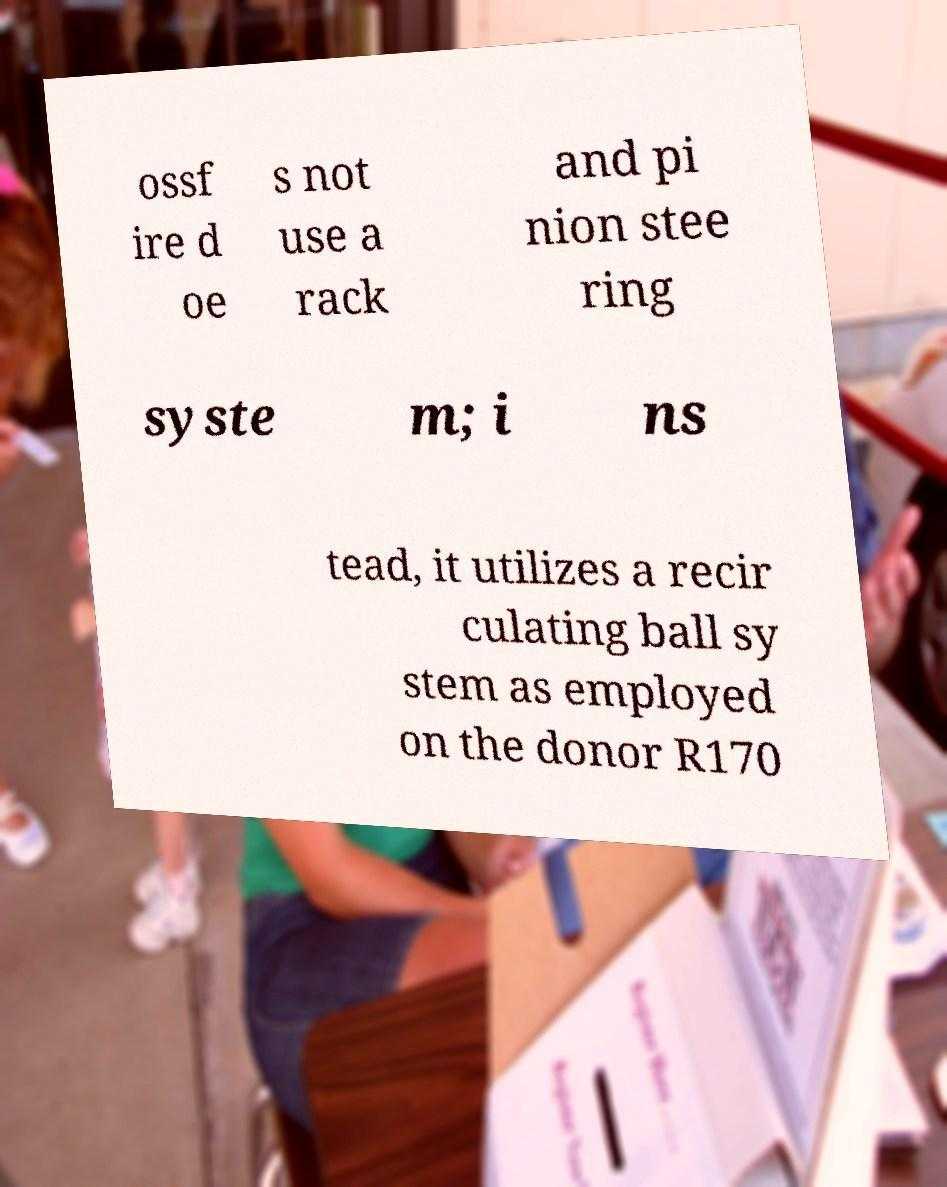Could you extract and type out the text from this image? ossf ire d oe s not use a rack and pi nion stee ring syste m; i ns tead, it utilizes a recir culating ball sy stem as employed on the donor R170 